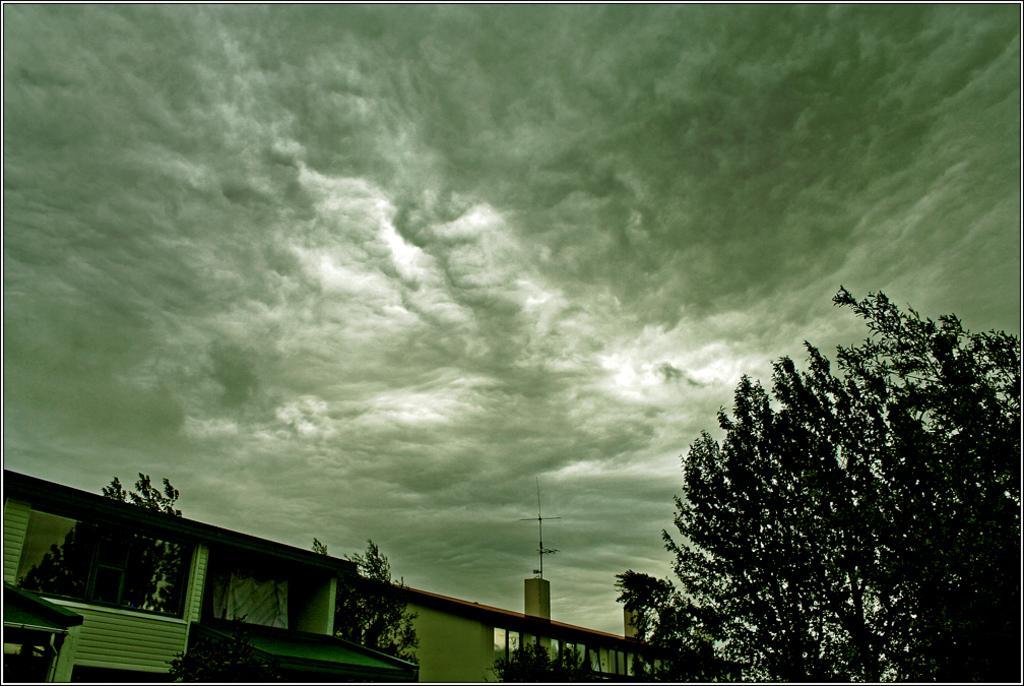Could you give a brief overview of what you see in this image? In the picture I can see a building, fence, trees and some other objects. In the background I can see the sky. 